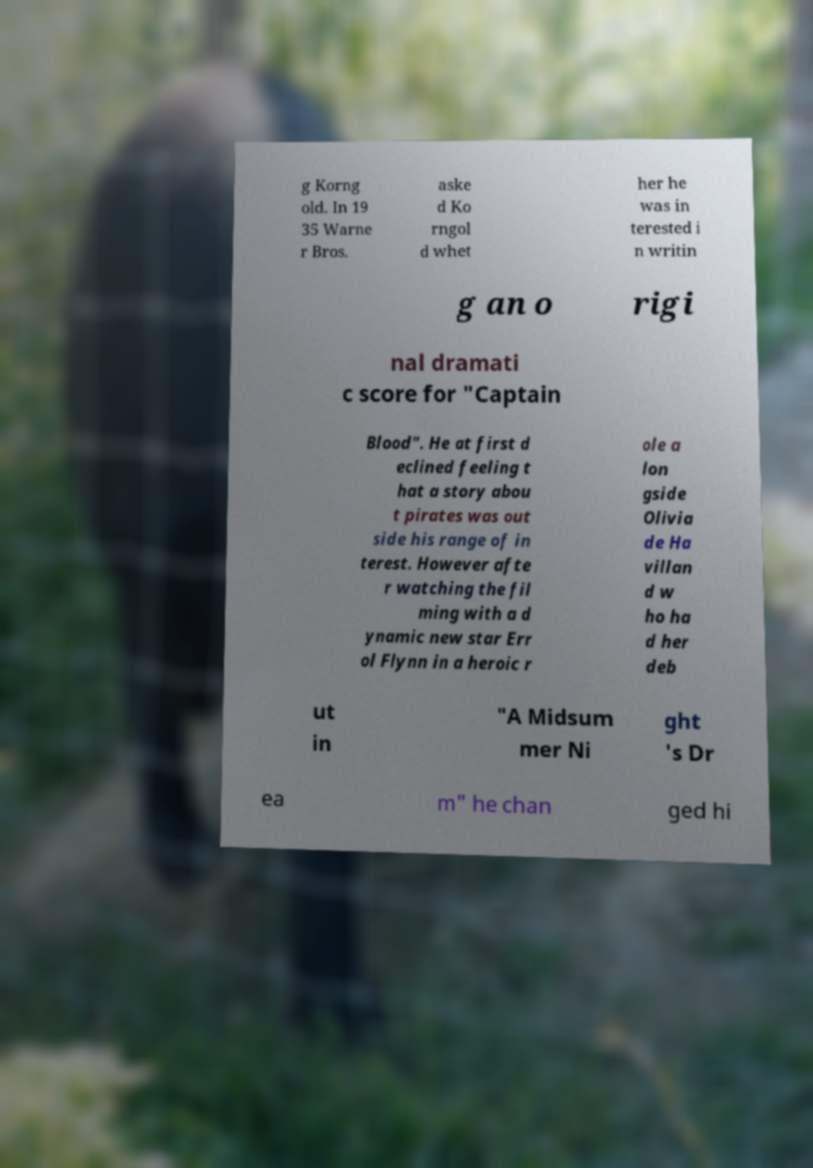Can you read and provide the text displayed in the image?This photo seems to have some interesting text. Can you extract and type it out for me? g Korng old. In 19 35 Warne r Bros. aske d Ko rngol d whet her he was in terested i n writin g an o rigi nal dramati c score for "Captain Blood". He at first d eclined feeling t hat a story abou t pirates was out side his range of in terest. However afte r watching the fil ming with a d ynamic new star Err ol Flynn in a heroic r ole a lon gside Olivia de Ha villan d w ho ha d her deb ut in "A Midsum mer Ni ght 's Dr ea m" he chan ged hi 